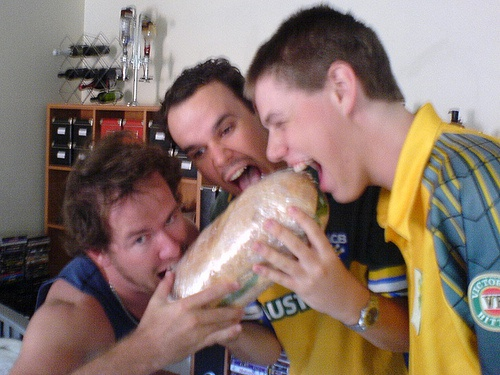Describe the objects in this image and their specific colors. I can see people in gray, lightpink, black, and gold tones, people in gray, brown, black, and maroon tones, people in gray, black, brown, olive, and lightpink tones, hot dog in gray, tan, lightgray, and darkgray tones, and sandwich in gray, tan, lightgray, and darkgray tones in this image. 